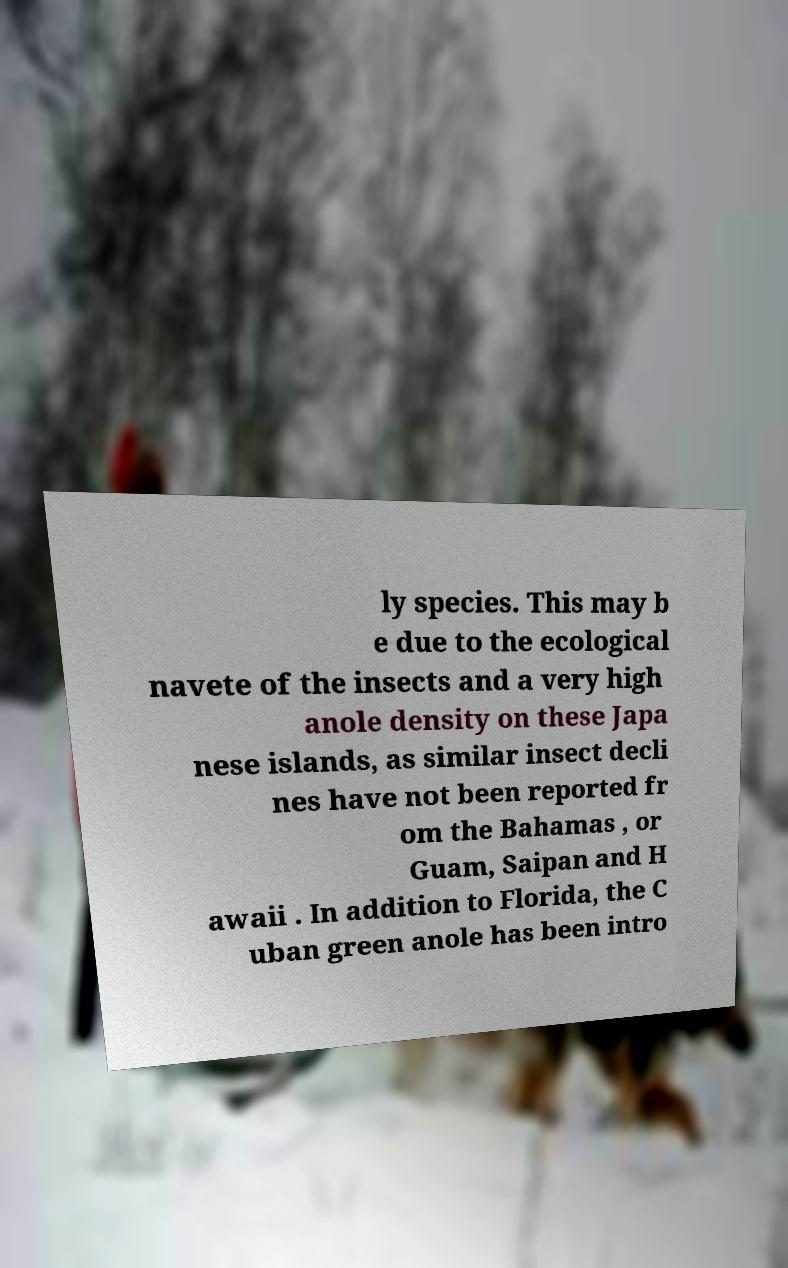I need the written content from this picture converted into text. Can you do that? ly species. This may b e due to the ecological navete of the insects and a very high anole density on these Japa nese islands, as similar insect decli nes have not been reported fr om the Bahamas , or Guam, Saipan and H awaii . In addition to Florida, the C uban green anole has been intro 